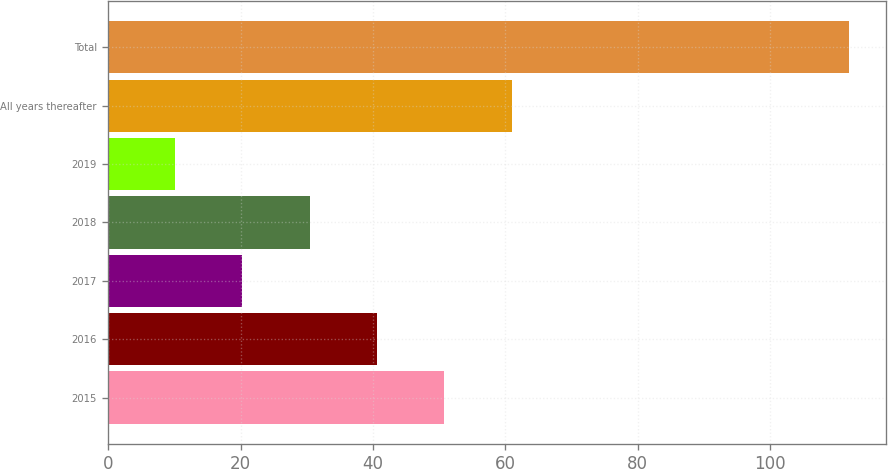<chart> <loc_0><loc_0><loc_500><loc_500><bar_chart><fcel>2015<fcel>2016<fcel>2017<fcel>2018<fcel>2019<fcel>All years thereafter<fcel>Total<nl><fcel>50.8<fcel>40.6<fcel>20.2<fcel>30.4<fcel>10<fcel>61<fcel>112<nl></chart> 